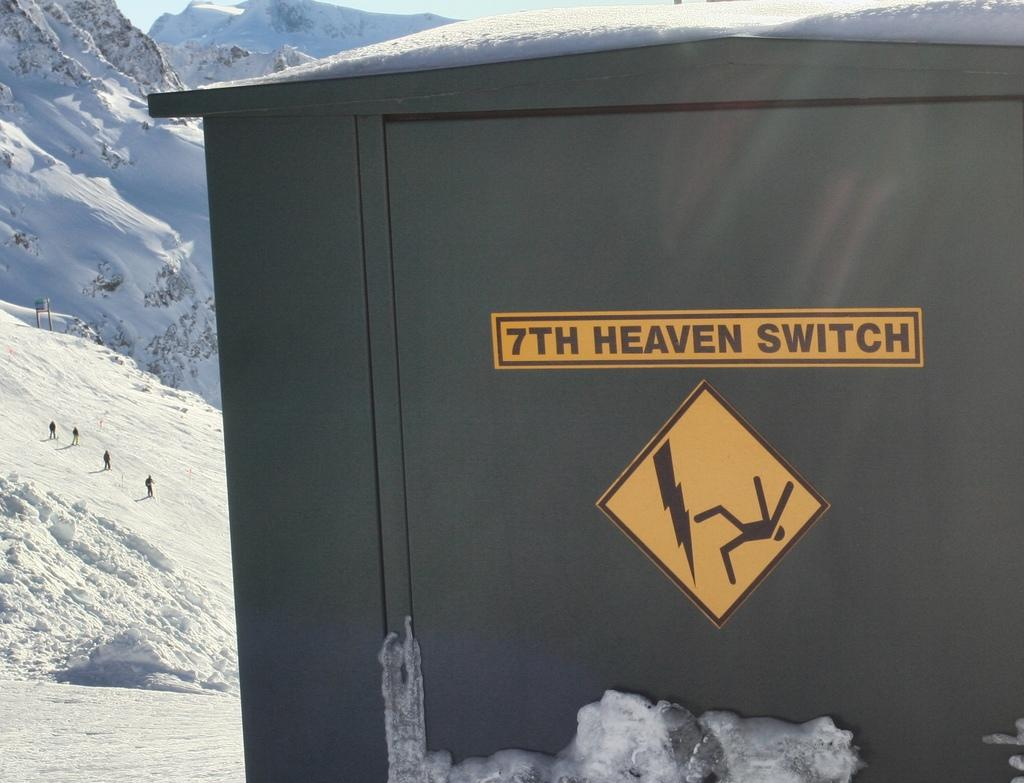<image>
Share a concise interpretation of the image provided. A building with a sign on it that says 7th Heaven Switch and warns of electricity. 